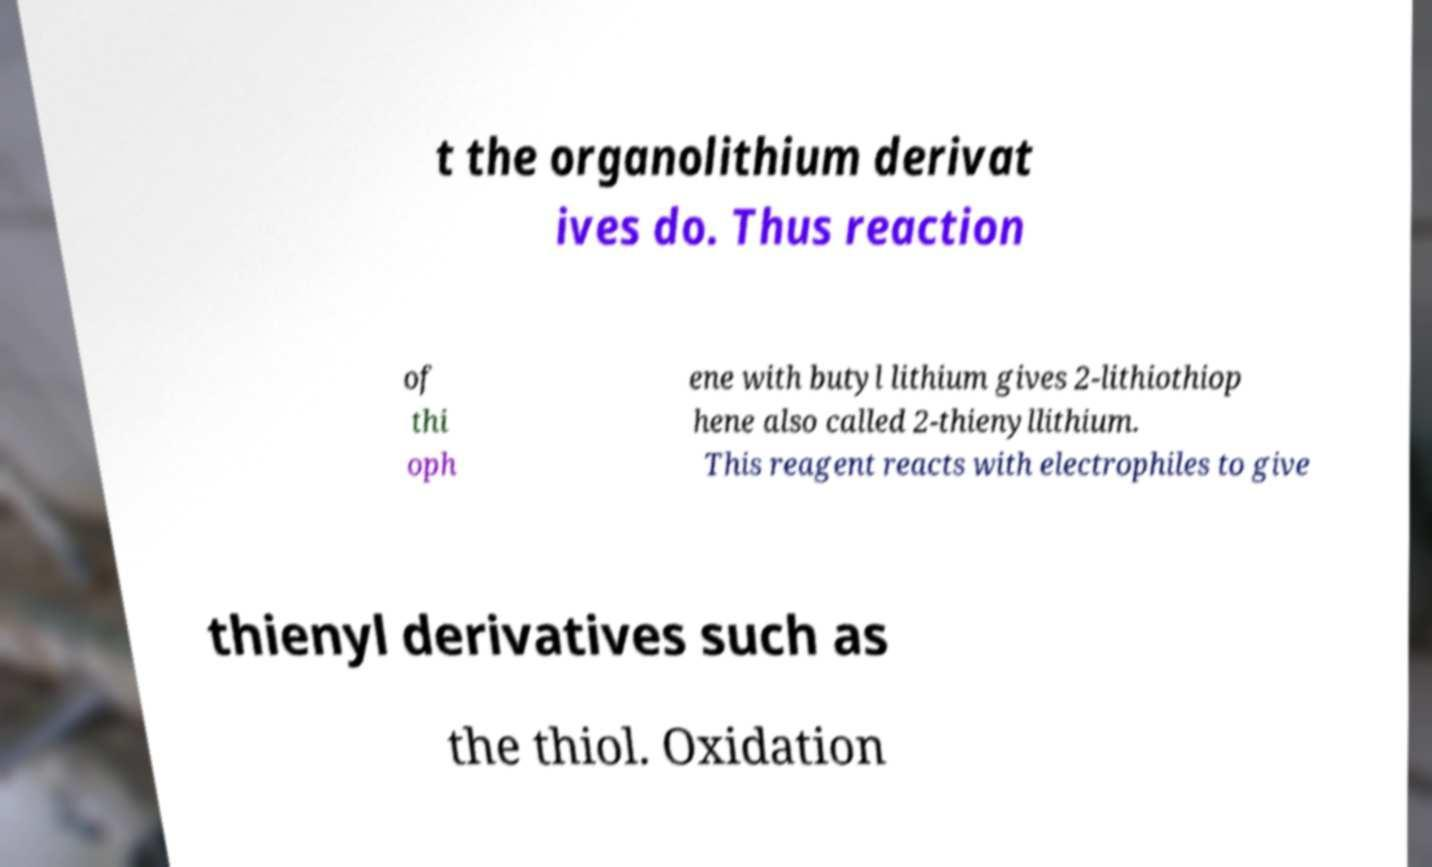Could you extract and type out the text from this image? t the organolithium derivat ives do. Thus reaction of thi oph ene with butyl lithium gives 2-lithiothiop hene also called 2-thienyllithium. This reagent reacts with electrophiles to give thienyl derivatives such as the thiol. Oxidation 